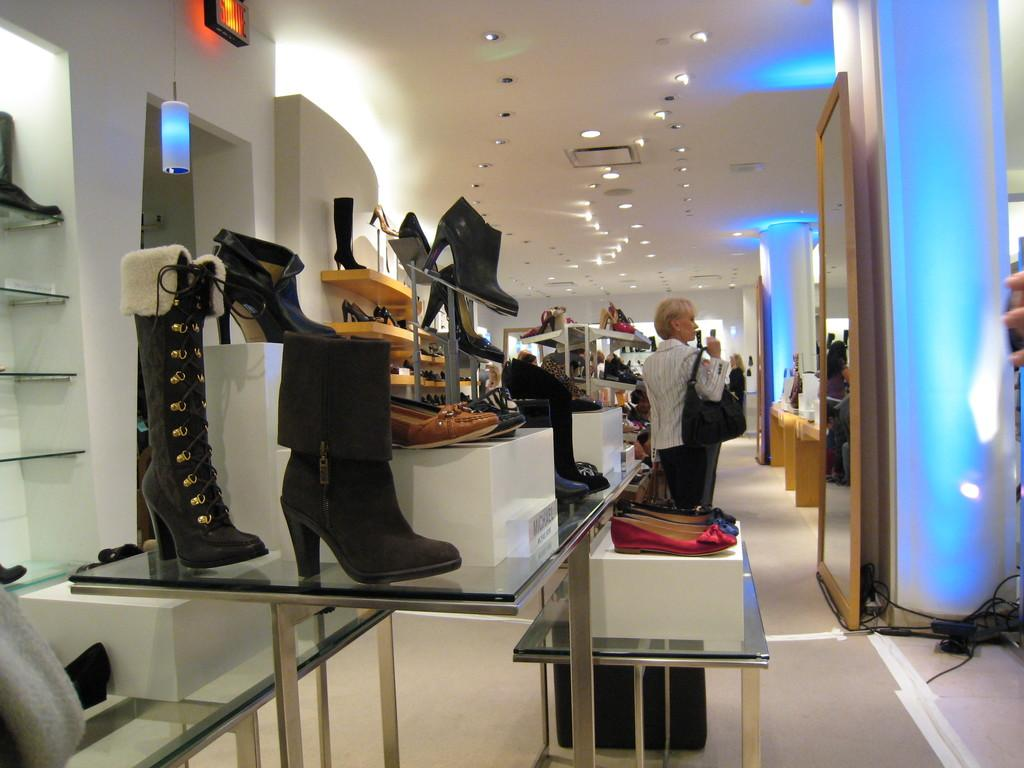What type of establishment is depicted in the image? The image is of a footwear shop. What furniture is present in the shop? There is a table in the shop. What is placed on the table? Shoes are placed on the table. What color is the rack in the shop? There is a yellow-colored rack in the shop. What is on the rack? Shoes are present on the rack. What is the woman in the shop doing? The woman is looking in a mirror. Can you tell me how many bears are on the boat in the image? There is no boat or bears present in the image; it is a footwear shop with shoes, a table, a yellow-colored rack, and a woman looking in a mirror. 